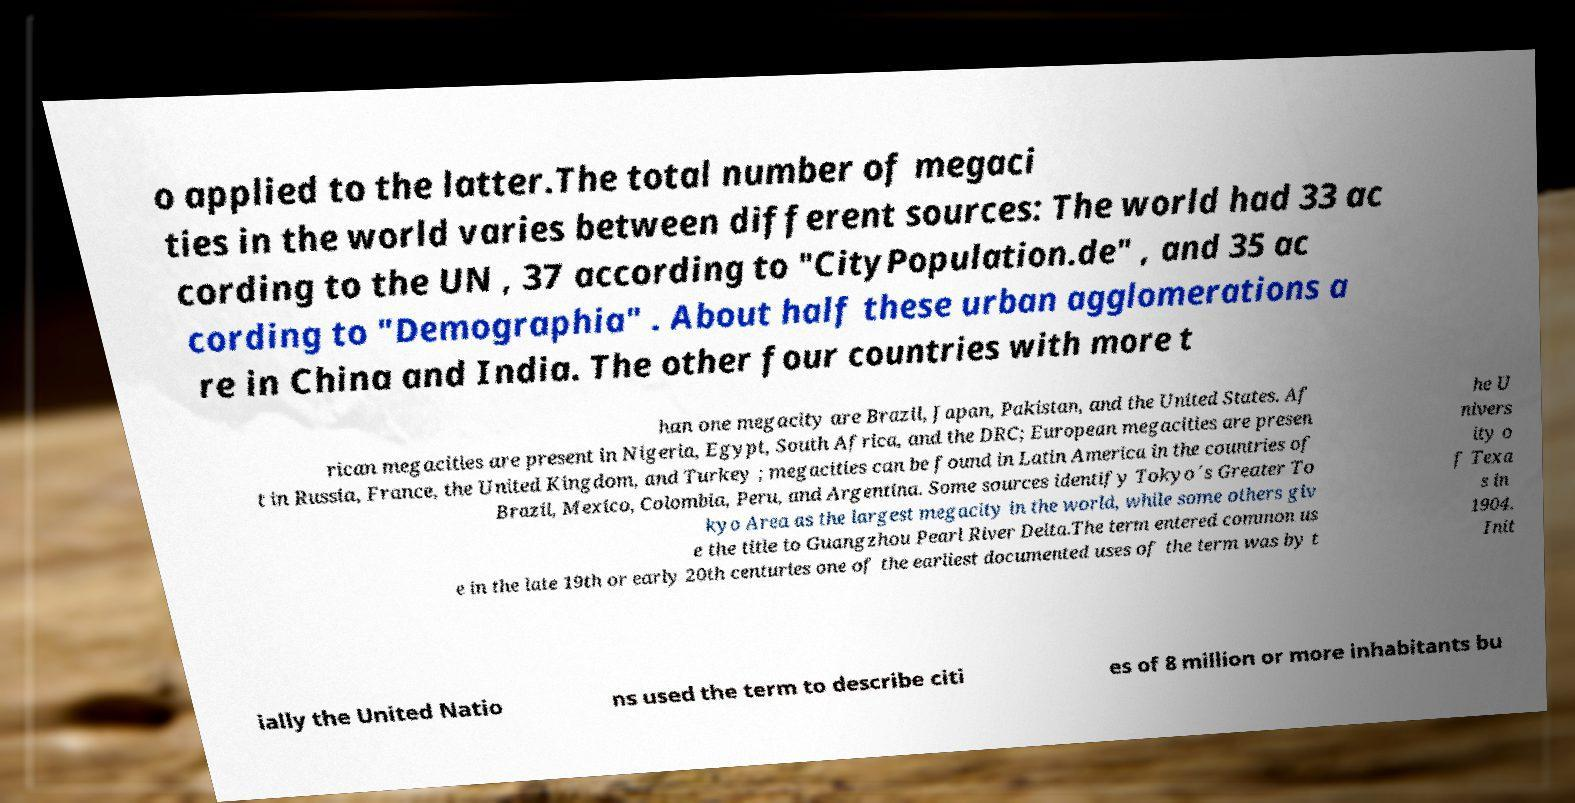I need the written content from this picture converted into text. Can you do that? o applied to the latter.The total number of megaci ties in the world varies between different sources: The world had 33 ac cording to the UN , 37 according to "CityPopulation.de" , and 35 ac cording to "Demographia" . About half these urban agglomerations a re in China and India. The other four countries with more t han one megacity are Brazil, Japan, Pakistan, and the United States. Af rican megacities are present in Nigeria, Egypt, South Africa, and the DRC; European megacities are presen t in Russia, France, the United Kingdom, and Turkey ; megacities can be found in Latin America in the countries of Brazil, Mexico, Colombia, Peru, and Argentina. Some sources identify Tokyo´s Greater To kyo Area as the largest megacity in the world, while some others giv e the title to Guangzhou Pearl River Delta.The term entered common us e in the late 19th or early 20th centuries one of the earliest documented uses of the term was by t he U nivers ity o f Texa s in 1904. Init ially the United Natio ns used the term to describe citi es of 8 million or more inhabitants bu 